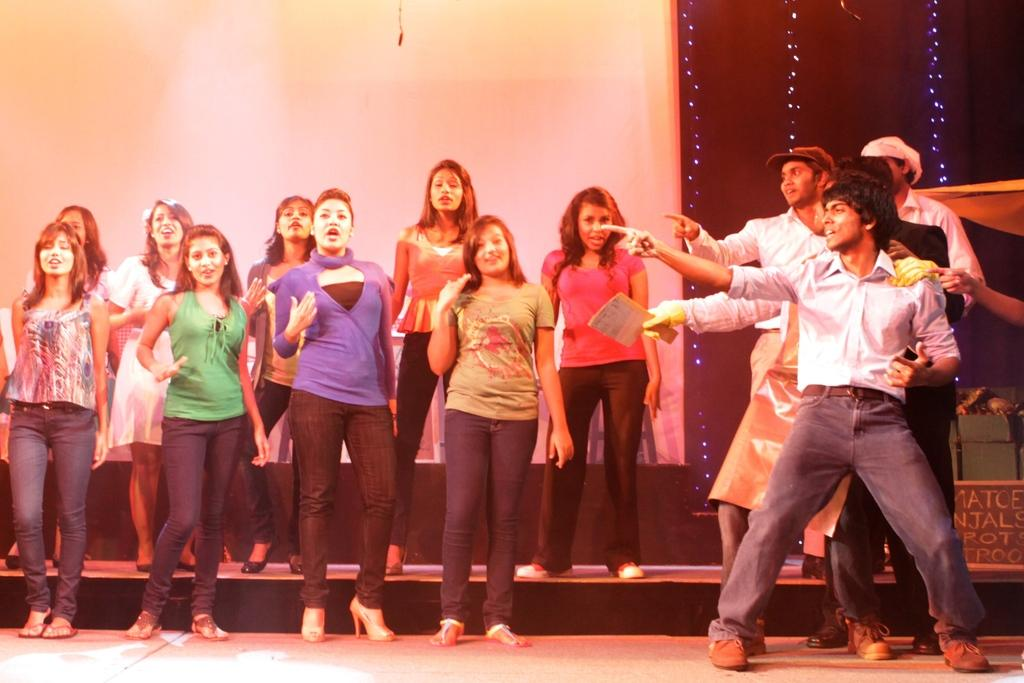What types of people are present in the image? There are men and women in the image. Where are the people located in the image? The people are standing on the floor. What can be seen in the background of the image? There are electric lights and walls in the background of the image. Can you tell me how many times the people in the image attempted to escape from jail? There is no indication in the image that the people are in jail or attempting to escape, so it cannot be determined from the picture. 